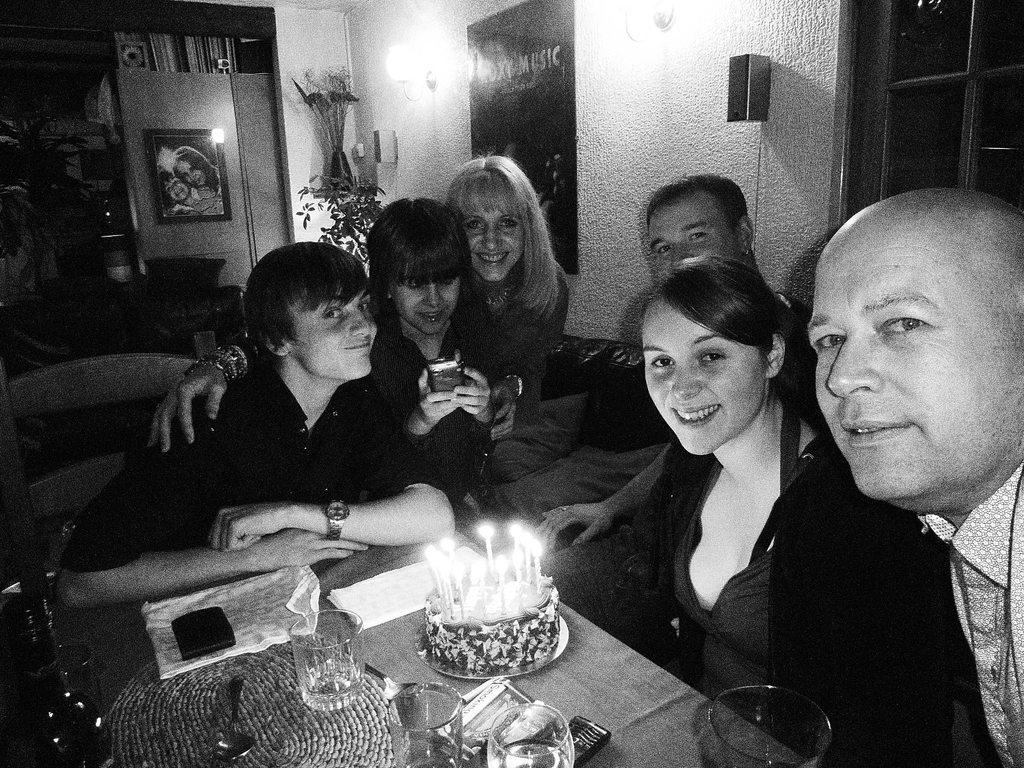Who or what can be seen in the image? There are people in the image. What are the people doing in the image? The people are sitting on chairs. What is the color scheme of the image? The image is in black and white color. What type of shade is being used by the people in the image? There is no shade visible in the image; it is in black and white color. What question are the people asking each other in the image? There is no indication of a conversation or question being asked in the image. 